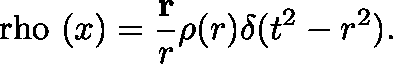<formula> <loc_0><loc_0><loc_500><loc_500>\boldmath \ r h o ( x ) = \frac { r } { r } \rho ( r ) \delta ( t ^ { 2 } - r ^ { 2 } ) .</formula> 